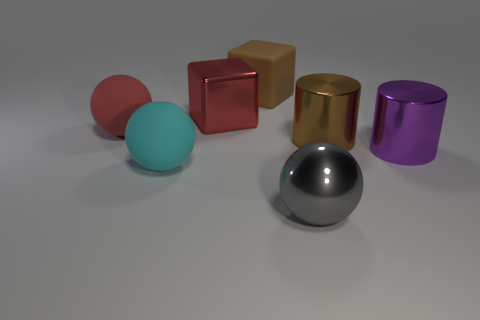How many other things are there of the same color as the large metallic sphere?
Your answer should be very brief. 0. Does the gray sphere have the same material as the large sphere that is behind the brown cylinder?
Ensure brevity in your answer.  No. Is the number of red cubes that are behind the cyan sphere greater than the number of big brown objects behind the brown rubber thing?
Provide a short and direct response. Yes. The big cube in front of the big brown thing that is on the left side of the large gray thing is what color?
Keep it short and to the point. Red. How many spheres are either large red matte things or brown objects?
Keep it short and to the point. 1. What number of things are both in front of the red shiny cube and to the right of the big cyan rubber sphere?
Your response must be concise. 3. What color is the shiny object to the left of the large metallic ball?
Provide a succinct answer. Red. How many cubes are behind the large metallic cylinder on the left side of the large purple cylinder?
Offer a very short reply. 2. How many brown objects are behind the red rubber ball?
Ensure brevity in your answer.  1. The big shiny object left of the large ball on the right side of the shiny object that is behind the brown metal thing is what color?
Your response must be concise. Red. 